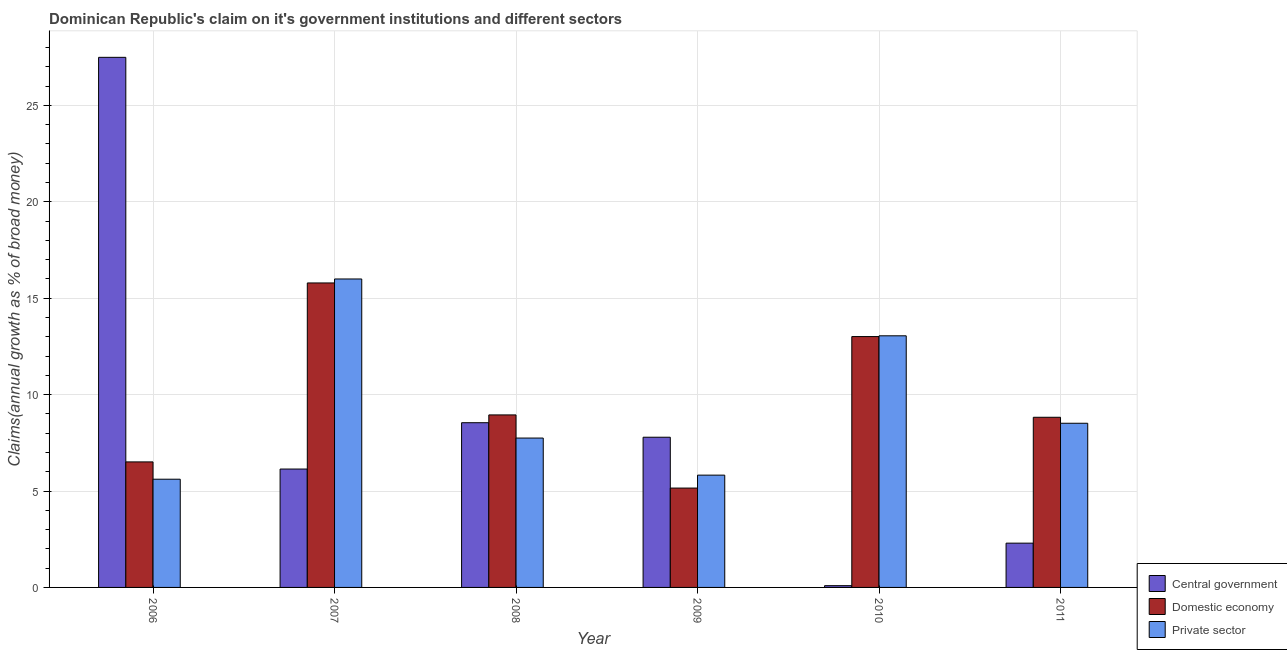How many different coloured bars are there?
Your answer should be very brief. 3. Are the number of bars per tick equal to the number of legend labels?
Offer a very short reply. Yes. Are the number of bars on each tick of the X-axis equal?
Give a very brief answer. Yes. How many bars are there on the 2nd tick from the left?
Make the answer very short. 3. How many bars are there on the 6th tick from the right?
Provide a short and direct response. 3. In how many cases, is the number of bars for a given year not equal to the number of legend labels?
Your response must be concise. 0. What is the percentage of claim on the domestic economy in 2006?
Offer a very short reply. 6.51. Across all years, what is the maximum percentage of claim on the private sector?
Offer a very short reply. 16. Across all years, what is the minimum percentage of claim on the domestic economy?
Provide a short and direct response. 5.15. What is the total percentage of claim on the central government in the graph?
Make the answer very short. 52.36. What is the difference between the percentage of claim on the domestic economy in 2006 and that in 2008?
Provide a succinct answer. -2.44. What is the difference between the percentage of claim on the domestic economy in 2006 and the percentage of claim on the private sector in 2009?
Keep it short and to the point. 1.36. What is the average percentage of claim on the central government per year?
Keep it short and to the point. 8.73. What is the ratio of the percentage of claim on the private sector in 2006 to that in 2008?
Your answer should be very brief. 0.72. What is the difference between the highest and the second highest percentage of claim on the domestic economy?
Keep it short and to the point. 2.78. What is the difference between the highest and the lowest percentage of claim on the domestic economy?
Your answer should be compact. 10.64. Is the sum of the percentage of claim on the private sector in 2007 and 2009 greater than the maximum percentage of claim on the central government across all years?
Ensure brevity in your answer.  Yes. What does the 2nd bar from the left in 2011 represents?
Make the answer very short. Domestic economy. What does the 2nd bar from the right in 2009 represents?
Give a very brief answer. Domestic economy. Is it the case that in every year, the sum of the percentage of claim on the central government and percentage of claim on the domestic economy is greater than the percentage of claim on the private sector?
Offer a very short reply. Yes. How many bars are there?
Keep it short and to the point. 18. Are all the bars in the graph horizontal?
Offer a terse response. No. Are the values on the major ticks of Y-axis written in scientific E-notation?
Offer a terse response. No. Does the graph contain grids?
Your answer should be very brief. Yes. Where does the legend appear in the graph?
Keep it short and to the point. Bottom right. How are the legend labels stacked?
Keep it short and to the point. Vertical. What is the title of the graph?
Your response must be concise. Dominican Republic's claim on it's government institutions and different sectors. What is the label or title of the X-axis?
Ensure brevity in your answer.  Year. What is the label or title of the Y-axis?
Provide a succinct answer. Claims(annual growth as % of broad money). What is the Claims(annual growth as % of broad money) of Central government in 2006?
Your answer should be very brief. 27.49. What is the Claims(annual growth as % of broad money) in Domestic economy in 2006?
Provide a succinct answer. 6.51. What is the Claims(annual growth as % of broad money) in Private sector in 2006?
Give a very brief answer. 5.61. What is the Claims(annual growth as % of broad money) in Central government in 2007?
Provide a short and direct response. 6.14. What is the Claims(annual growth as % of broad money) of Domestic economy in 2007?
Your answer should be compact. 15.79. What is the Claims(annual growth as % of broad money) of Private sector in 2007?
Make the answer very short. 16. What is the Claims(annual growth as % of broad money) in Central government in 2008?
Your response must be concise. 8.54. What is the Claims(annual growth as % of broad money) of Domestic economy in 2008?
Keep it short and to the point. 8.95. What is the Claims(annual growth as % of broad money) of Private sector in 2008?
Make the answer very short. 7.75. What is the Claims(annual growth as % of broad money) of Central government in 2009?
Your answer should be compact. 7.79. What is the Claims(annual growth as % of broad money) of Domestic economy in 2009?
Your answer should be very brief. 5.15. What is the Claims(annual growth as % of broad money) in Private sector in 2009?
Your response must be concise. 5.82. What is the Claims(annual growth as % of broad money) of Central government in 2010?
Ensure brevity in your answer.  0.09. What is the Claims(annual growth as % of broad money) of Domestic economy in 2010?
Ensure brevity in your answer.  13.01. What is the Claims(annual growth as % of broad money) in Private sector in 2010?
Give a very brief answer. 13.05. What is the Claims(annual growth as % of broad money) of Central government in 2011?
Provide a succinct answer. 2.3. What is the Claims(annual growth as % of broad money) of Domestic economy in 2011?
Ensure brevity in your answer.  8.83. What is the Claims(annual growth as % of broad money) in Private sector in 2011?
Offer a very short reply. 8.51. Across all years, what is the maximum Claims(annual growth as % of broad money) of Central government?
Keep it short and to the point. 27.49. Across all years, what is the maximum Claims(annual growth as % of broad money) in Domestic economy?
Ensure brevity in your answer.  15.79. Across all years, what is the maximum Claims(annual growth as % of broad money) in Private sector?
Give a very brief answer. 16. Across all years, what is the minimum Claims(annual growth as % of broad money) of Central government?
Offer a very short reply. 0.09. Across all years, what is the minimum Claims(annual growth as % of broad money) in Domestic economy?
Ensure brevity in your answer.  5.15. Across all years, what is the minimum Claims(annual growth as % of broad money) in Private sector?
Ensure brevity in your answer.  5.61. What is the total Claims(annual growth as % of broad money) of Central government in the graph?
Your answer should be very brief. 52.36. What is the total Claims(annual growth as % of broad money) of Domestic economy in the graph?
Provide a succinct answer. 58.24. What is the total Claims(annual growth as % of broad money) in Private sector in the graph?
Give a very brief answer. 56.75. What is the difference between the Claims(annual growth as % of broad money) of Central government in 2006 and that in 2007?
Make the answer very short. 21.35. What is the difference between the Claims(annual growth as % of broad money) in Domestic economy in 2006 and that in 2007?
Your answer should be compact. -9.28. What is the difference between the Claims(annual growth as % of broad money) in Private sector in 2006 and that in 2007?
Your answer should be very brief. -10.39. What is the difference between the Claims(annual growth as % of broad money) in Central government in 2006 and that in 2008?
Your answer should be very brief. 18.95. What is the difference between the Claims(annual growth as % of broad money) in Domestic economy in 2006 and that in 2008?
Offer a terse response. -2.44. What is the difference between the Claims(annual growth as % of broad money) in Private sector in 2006 and that in 2008?
Your response must be concise. -2.13. What is the difference between the Claims(annual growth as % of broad money) of Central government in 2006 and that in 2009?
Ensure brevity in your answer.  19.7. What is the difference between the Claims(annual growth as % of broad money) in Domestic economy in 2006 and that in 2009?
Your answer should be compact. 1.36. What is the difference between the Claims(annual growth as % of broad money) in Private sector in 2006 and that in 2009?
Provide a short and direct response. -0.21. What is the difference between the Claims(annual growth as % of broad money) of Central government in 2006 and that in 2010?
Provide a short and direct response. 27.4. What is the difference between the Claims(annual growth as % of broad money) of Domestic economy in 2006 and that in 2010?
Your answer should be compact. -6.5. What is the difference between the Claims(annual growth as % of broad money) in Private sector in 2006 and that in 2010?
Your answer should be compact. -7.44. What is the difference between the Claims(annual growth as % of broad money) in Central government in 2006 and that in 2011?
Offer a terse response. 25.2. What is the difference between the Claims(annual growth as % of broad money) of Domestic economy in 2006 and that in 2011?
Make the answer very short. -2.31. What is the difference between the Claims(annual growth as % of broad money) of Private sector in 2006 and that in 2011?
Ensure brevity in your answer.  -2.9. What is the difference between the Claims(annual growth as % of broad money) in Central government in 2007 and that in 2008?
Your response must be concise. -2.4. What is the difference between the Claims(annual growth as % of broad money) of Domestic economy in 2007 and that in 2008?
Offer a very short reply. 6.84. What is the difference between the Claims(annual growth as % of broad money) in Private sector in 2007 and that in 2008?
Provide a short and direct response. 8.25. What is the difference between the Claims(annual growth as % of broad money) in Central government in 2007 and that in 2009?
Give a very brief answer. -1.65. What is the difference between the Claims(annual growth as % of broad money) in Domestic economy in 2007 and that in 2009?
Make the answer very short. 10.64. What is the difference between the Claims(annual growth as % of broad money) of Private sector in 2007 and that in 2009?
Offer a very short reply. 10.17. What is the difference between the Claims(annual growth as % of broad money) of Central government in 2007 and that in 2010?
Offer a very short reply. 6.05. What is the difference between the Claims(annual growth as % of broad money) in Domestic economy in 2007 and that in 2010?
Provide a short and direct response. 2.78. What is the difference between the Claims(annual growth as % of broad money) in Private sector in 2007 and that in 2010?
Make the answer very short. 2.95. What is the difference between the Claims(annual growth as % of broad money) in Central government in 2007 and that in 2011?
Provide a short and direct response. 3.84. What is the difference between the Claims(annual growth as % of broad money) in Domestic economy in 2007 and that in 2011?
Ensure brevity in your answer.  6.97. What is the difference between the Claims(annual growth as % of broad money) in Private sector in 2007 and that in 2011?
Make the answer very short. 7.48. What is the difference between the Claims(annual growth as % of broad money) of Central government in 2008 and that in 2009?
Your answer should be compact. 0.75. What is the difference between the Claims(annual growth as % of broad money) of Domestic economy in 2008 and that in 2009?
Make the answer very short. 3.79. What is the difference between the Claims(annual growth as % of broad money) of Private sector in 2008 and that in 2009?
Offer a terse response. 1.92. What is the difference between the Claims(annual growth as % of broad money) in Central government in 2008 and that in 2010?
Provide a succinct answer. 8.45. What is the difference between the Claims(annual growth as % of broad money) of Domestic economy in 2008 and that in 2010?
Offer a terse response. -4.06. What is the difference between the Claims(annual growth as % of broad money) of Private sector in 2008 and that in 2010?
Make the answer very short. -5.3. What is the difference between the Claims(annual growth as % of broad money) of Central government in 2008 and that in 2011?
Your answer should be very brief. 6.25. What is the difference between the Claims(annual growth as % of broad money) of Domestic economy in 2008 and that in 2011?
Offer a terse response. 0.12. What is the difference between the Claims(annual growth as % of broad money) in Private sector in 2008 and that in 2011?
Provide a short and direct response. -0.77. What is the difference between the Claims(annual growth as % of broad money) of Central government in 2009 and that in 2010?
Give a very brief answer. 7.7. What is the difference between the Claims(annual growth as % of broad money) of Domestic economy in 2009 and that in 2010?
Make the answer very short. -7.86. What is the difference between the Claims(annual growth as % of broad money) of Private sector in 2009 and that in 2010?
Provide a short and direct response. -7.23. What is the difference between the Claims(annual growth as % of broad money) in Central government in 2009 and that in 2011?
Keep it short and to the point. 5.49. What is the difference between the Claims(annual growth as % of broad money) of Domestic economy in 2009 and that in 2011?
Make the answer very short. -3.67. What is the difference between the Claims(annual growth as % of broad money) in Private sector in 2009 and that in 2011?
Your answer should be compact. -2.69. What is the difference between the Claims(annual growth as % of broad money) in Central government in 2010 and that in 2011?
Your response must be concise. -2.21. What is the difference between the Claims(annual growth as % of broad money) in Domestic economy in 2010 and that in 2011?
Keep it short and to the point. 4.19. What is the difference between the Claims(annual growth as % of broad money) in Private sector in 2010 and that in 2011?
Make the answer very short. 4.54. What is the difference between the Claims(annual growth as % of broad money) of Central government in 2006 and the Claims(annual growth as % of broad money) of Domestic economy in 2007?
Provide a short and direct response. 11.7. What is the difference between the Claims(annual growth as % of broad money) in Central government in 2006 and the Claims(annual growth as % of broad money) in Private sector in 2007?
Provide a succinct answer. 11.5. What is the difference between the Claims(annual growth as % of broad money) in Domestic economy in 2006 and the Claims(annual growth as % of broad money) in Private sector in 2007?
Your answer should be compact. -9.49. What is the difference between the Claims(annual growth as % of broad money) of Central government in 2006 and the Claims(annual growth as % of broad money) of Domestic economy in 2008?
Give a very brief answer. 18.55. What is the difference between the Claims(annual growth as % of broad money) of Central government in 2006 and the Claims(annual growth as % of broad money) of Private sector in 2008?
Give a very brief answer. 19.75. What is the difference between the Claims(annual growth as % of broad money) in Domestic economy in 2006 and the Claims(annual growth as % of broad money) in Private sector in 2008?
Your answer should be very brief. -1.24. What is the difference between the Claims(annual growth as % of broad money) of Central government in 2006 and the Claims(annual growth as % of broad money) of Domestic economy in 2009?
Provide a short and direct response. 22.34. What is the difference between the Claims(annual growth as % of broad money) of Central government in 2006 and the Claims(annual growth as % of broad money) of Private sector in 2009?
Your response must be concise. 21.67. What is the difference between the Claims(annual growth as % of broad money) of Domestic economy in 2006 and the Claims(annual growth as % of broad money) of Private sector in 2009?
Make the answer very short. 0.69. What is the difference between the Claims(annual growth as % of broad money) in Central government in 2006 and the Claims(annual growth as % of broad money) in Domestic economy in 2010?
Offer a terse response. 14.48. What is the difference between the Claims(annual growth as % of broad money) of Central government in 2006 and the Claims(annual growth as % of broad money) of Private sector in 2010?
Offer a very short reply. 14.44. What is the difference between the Claims(annual growth as % of broad money) in Domestic economy in 2006 and the Claims(annual growth as % of broad money) in Private sector in 2010?
Provide a succinct answer. -6.54. What is the difference between the Claims(annual growth as % of broad money) in Central government in 2006 and the Claims(annual growth as % of broad money) in Domestic economy in 2011?
Provide a short and direct response. 18.67. What is the difference between the Claims(annual growth as % of broad money) in Central government in 2006 and the Claims(annual growth as % of broad money) in Private sector in 2011?
Provide a succinct answer. 18.98. What is the difference between the Claims(annual growth as % of broad money) of Domestic economy in 2006 and the Claims(annual growth as % of broad money) of Private sector in 2011?
Provide a succinct answer. -2. What is the difference between the Claims(annual growth as % of broad money) of Central government in 2007 and the Claims(annual growth as % of broad money) of Domestic economy in 2008?
Your answer should be compact. -2.81. What is the difference between the Claims(annual growth as % of broad money) of Central government in 2007 and the Claims(annual growth as % of broad money) of Private sector in 2008?
Provide a succinct answer. -1.61. What is the difference between the Claims(annual growth as % of broad money) in Domestic economy in 2007 and the Claims(annual growth as % of broad money) in Private sector in 2008?
Provide a succinct answer. 8.04. What is the difference between the Claims(annual growth as % of broad money) in Central government in 2007 and the Claims(annual growth as % of broad money) in Domestic economy in 2009?
Your response must be concise. 0.99. What is the difference between the Claims(annual growth as % of broad money) of Central government in 2007 and the Claims(annual growth as % of broad money) of Private sector in 2009?
Your answer should be compact. 0.32. What is the difference between the Claims(annual growth as % of broad money) in Domestic economy in 2007 and the Claims(annual growth as % of broad money) in Private sector in 2009?
Provide a short and direct response. 9.97. What is the difference between the Claims(annual growth as % of broad money) in Central government in 2007 and the Claims(annual growth as % of broad money) in Domestic economy in 2010?
Give a very brief answer. -6.87. What is the difference between the Claims(annual growth as % of broad money) of Central government in 2007 and the Claims(annual growth as % of broad money) of Private sector in 2010?
Your answer should be very brief. -6.91. What is the difference between the Claims(annual growth as % of broad money) in Domestic economy in 2007 and the Claims(annual growth as % of broad money) in Private sector in 2010?
Keep it short and to the point. 2.74. What is the difference between the Claims(annual growth as % of broad money) of Central government in 2007 and the Claims(annual growth as % of broad money) of Domestic economy in 2011?
Provide a short and direct response. -2.69. What is the difference between the Claims(annual growth as % of broad money) of Central government in 2007 and the Claims(annual growth as % of broad money) of Private sector in 2011?
Your answer should be very brief. -2.37. What is the difference between the Claims(annual growth as % of broad money) in Domestic economy in 2007 and the Claims(annual growth as % of broad money) in Private sector in 2011?
Make the answer very short. 7.28. What is the difference between the Claims(annual growth as % of broad money) in Central government in 2008 and the Claims(annual growth as % of broad money) in Domestic economy in 2009?
Keep it short and to the point. 3.39. What is the difference between the Claims(annual growth as % of broad money) in Central government in 2008 and the Claims(annual growth as % of broad money) in Private sector in 2009?
Give a very brief answer. 2.72. What is the difference between the Claims(annual growth as % of broad money) in Domestic economy in 2008 and the Claims(annual growth as % of broad money) in Private sector in 2009?
Give a very brief answer. 3.12. What is the difference between the Claims(annual growth as % of broad money) in Central government in 2008 and the Claims(annual growth as % of broad money) in Domestic economy in 2010?
Your answer should be compact. -4.47. What is the difference between the Claims(annual growth as % of broad money) of Central government in 2008 and the Claims(annual growth as % of broad money) of Private sector in 2010?
Give a very brief answer. -4.51. What is the difference between the Claims(annual growth as % of broad money) in Domestic economy in 2008 and the Claims(annual growth as % of broad money) in Private sector in 2010?
Provide a succinct answer. -4.1. What is the difference between the Claims(annual growth as % of broad money) in Central government in 2008 and the Claims(annual growth as % of broad money) in Domestic economy in 2011?
Your response must be concise. -0.28. What is the difference between the Claims(annual growth as % of broad money) of Central government in 2008 and the Claims(annual growth as % of broad money) of Private sector in 2011?
Make the answer very short. 0.03. What is the difference between the Claims(annual growth as % of broad money) of Domestic economy in 2008 and the Claims(annual growth as % of broad money) of Private sector in 2011?
Provide a short and direct response. 0.43. What is the difference between the Claims(annual growth as % of broad money) of Central government in 2009 and the Claims(annual growth as % of broad money) of Domestic economy in 2010?
Offer a terse response. -5.22. What is the difference between the Claims(annual growth as % of broad money) in Central government in 2009 and the Claims(annual growth as % of broad money) in Private sector in 2010?
Ensure brevity in your answer.  -5.26. What is the difference between the Claims(annual growth as % of broad money) in Domestic economy in 2009 and the Claims(annual growth as % of broad money) in Private sector in 2010?
Ensure brevity in your answer.  -7.9. What is the difference between the Claims(annual growth as % of broad money) in Central government in 2009 and the Claims(annual growth as % of broad money) in Domestic economy in 2011?
Your answer should be compact. -1.03. What is the difference between the Claims(annual growth as % of broad money) in Central government in 2009 and the Claims(annual growth as % of broad money) in Private sector in 2011?
Provide a succinct answer. -0.72. What is the difference between the Claims(annual growth as % of broad money) of Domestic economy in 2009 and the Claims(annual growth as % of broad money) of Private sector in 2011?
Give a very brief answer. -3.36. What is the difference between the Claims(annual growth as % of broad money) in Central government in 2010 and the Claims(annual growth as % of broad money) in Domestic economy in 2011?
Give a very brief answer. -8.73. What is the difference between the Claims(annual growth as % of broad money) in Central government in 2010 and the Claims(annual growth as % of broad money) in Private sector in 2011?
Your answer should be very brief. -8.42. What is the difference between the Claims(annual growth as % of broad money) in Domestic economy in 2010 and the Claims(annual growth as % of broad money) in Private sector in 2011?
Provide a succinct answer. 4.5. What is the average Claims(annual growth as % of broad money) in Central government per year?
Your answer should be very brief. 8.73. What is the average Claims(annual growth as % of broad money) of Domestic economy per year?
Provide a succinct answer. 9.71. What is the average Claims(annual growth as % of broad money) in Private sector per year?
Give a very brief answer. 9.46. In the year 2006, what is the difference between the Claims(annual growth as % of broad money) of Central government and Claims(annual growth as % of broad money) of Domestic economy?
Provide a short and direct response. 20.98. In the year 2006, what is the difference between the Claims(annual growth as % of broad money) in Central government and Claims(annual growth as % of broad money) in Private sector?
Offer a very short reply. 21.88. In the year 2006, what is the difference between the Claims(annual growth as % of broad money) of Domestic economy and Claims(annual growth as % of broad money) of Private sector?
Your answer should be very brief. 0.9. In the year 2007, what is the difference between the Claims(annual growth as % of broad money) in Central government and Claims(annual growth as % of broad money) in Domestic economy?
Your response must be concise. -9.65. In the year 2007, what is the difference between the Claims(annual growth as % of broad money) of Central government and Claims(annual growth as % of broad money) of Private sector?
Ensure brevity in your answer.  -9.86. In the year 2007, what is the difference between the Claims(annual growth as % of broad money) in Domestic economy and Claims(annual growth as % of broad money) in Private sector?
Provide a succinct answer. -0.21. In the year 2008, what is the difference between the Claims(annual growth as % of broad money) of Central government and Claims(annual growth as % of broad money) of Domestic economy?
Ensure brevity in your answer.  -0.4. In the year 2008, what is the difference between the Claims(annual growth as % of broad money) of Central government and Claims(annual growth as % of broad money) of Private sector?
Offer a very short reply. 0.8. In the year 2008, what is the difference between the Claims(annual growth as % of broad money) of Domestic economy and Claims(annual growth as % of broad money) of Private sector?
Ensure brevity in your answer.  1.2. In the year 2009, what is the difference between the Claims(annual growth as % of broad money) in Central government and Claims(annual growth as % of broad money) in Domestic economy?
Provide a succinct answer. 2.64. In the year 2009, what is the difference between the Claims(annual growth as % of broad money) of Central government and Claims(annual growth as % of broad money) of Private sector?
Make the answer very short. 1.97. In the year 2009, what is the difference between the Claims(annual growth as % of broad money) in Domestic economy and Claims(annual growth as % of broad money) in Private sector?
Ensure brevity in your answer.  -0.67. In the year 2010, what is the difference between the Claims(annual growth as % of broad money) of Central government and Claims(annual growth as % of broad money) of Domestic economy?
Your answer should be compact. -12.92. In the year 2010, what is the difference between the Claims(annual growth as % of broad money) of Central government and Claims(annual growth as % of broad money) of Private sector?
Your answer should be compact. -12.96. In the year 2010, what is the difference between the Claims(annual growth as % of broad money) of Domestic economy and Claims(annual growth as % of broad money) of Private sector?
Your response must be concise. -0.04. In the year 2011, what is the difference between the Claims(annual growth as % of broad money) in Central government and Claims(annual growth as % of broad money) in Domestic economy?
Your answer should be very brief. -6.53. In the year 2011, what is the difference between the Claims(annual growth as % of broad money) of Central government and Claims(annual growth as % of broad money) of Private sector?
Provide a succinct answer. -6.22. In the year 2011, what is the difference between the Claims(annual growth as % of broad money) in Domestic economy and Claims(annual growth as % of broad money) in Private sector?
Offer a very short reply. 0.31. What is the ratio of the Claims(annual growth as % of broad money) of Central government in 2006 to that in 2007?
Provide a succinct answer. 4.48. What is the ratio of the Claims(annual growth as % of broad money) of Domestic economy in 2006 to that in 2007?
Offer a terse response. 0.41. What is the ratio of the Claims(annual growth as % of broad money) in Private sector in 2006 to that in 2007?
Provide a short and direct response. 0.35. What is the ratio of the Claims(annual growth as % of broad money) in Central government in 2006 to that in 2008?
Your answer should be compact. 3.22. What is the ratio of the Claims(annual growth as % of broad money) of Domestic economy in 2006 to that in 2008?
Your response must be concise. 0.73. What is the ratio of the Claims(annual growth as % of broad money) in Private sector in 2006 to that in 2008?
Give a very brief answer. 0.72. What is the ratio of the Claims(annual growth as % of broad money) in Central government in 2006 to that in 2009?
Provide a short and direct response. 3.53. What is the ratio of the Claims(annual growth as % of broad money) in Domestic economy in 2006 to that in 2009?
Ensure brevity in your answer.  1.26. What is the ratio of the Claims(annual growth as % of broad money) of Private sector in 2006 to that in 2009?
Your response must be concise. 0.96. What is the ratio of the Claims(annual growth as % of broad money) of Central government in 2006 to that in 2010?
Make the answer very short. 300.95. What is the ratio of the Claims(annual growth as % of broad money) of Domestic economy in 2006 to that in 2010?
Ensure brevity in your answer.  0.5. What is the ratio of the Claims(annual growth as % of broad money) in Private sector in 2006 to that in 2010?
Keep it short and to the point. 0.43. What is the ratio of the Claims(annual growth as % of broad money) in Central government in 2006 to that in 2011?
Your answer should be compact. 11.97. What is the ratio of the Claims(annual growth as % of broad money) of Domestic economy in 2006 to that in 2011?
Your answer should be compact. 0.74. What is the ratio of the Claims(annual growth as % of broad money) of Private sector in 2006 to that in 2011?
Provide a short and direct response. 0.66. What is the ratio of the Claims(annual growth as % of broad money) in Central government in 2007 to that in 2008?
Offer a very short reply. 0.72. What is the ratio of the Claims(annual growth as % of broad money) in Domestic economy in 2007 to that in 2008?
Your response must be concise. 1.76. What is the ratio of the Claims(annual growth as % of broad money) of Private sector in 2007 to that in 2008?
Provide a short and direct response. 2.06. What is the ratio of the Claims(annual growth as % of broad money) of Central government in 2007 to that in 2009?
Provide a short and direct response. 0.79. What is the ratio of the Claims(annual growth as % of broad money) in Domestic economy in 2007 to that in 2009?
Ensure brevity in your answer.  3.06. What is the ratio of the Claims(annual growth as % of broad money) in Private sector in 2007 to that in 2009?
Offer a terse response. 2.75. What is the ratio of the Claims(annual growth as % of broad money) in Central government in 2007 to that in 2010?
Give a very brief answer. 67.21. What is the ratio of the Claims(annual growth as % of broad money) in Domestic economy in 2007 to that in 2010?
Offer a very short reply. 1.21. What is the ratio of the Claims(annual growth as % of broad money) of Private sector in 2007 to that in 2010?
Offer a very short reply. 1.23. What is the ratio of the Claims(annual growth as % of broad money) in Central government in 2007 to that in 2011?
Your answer should be compact. 2.67. What is the ratio of the Claims(annual growth as % of broad money) of Domestic economy in 2007 to that in 2011?
Your answer should be compact. 1.79. What is the ratio of the Claims(annual growth as % of broad money) of Private sector in 2007 to that in 2011?
Offer a very short reply. 1.88. What is the ratio of the Claims(annual growth as % of broad money) of Central government in 2008 to that in 2009?
Provide a short and direct response. 1.1. What is the ratio of the Claims(annual growth as % of broad money) of Domestic economy in 2008 to that in 2009?
Give a very brief answer. 1.74. What is the ratio of the Claims(annual growth as % of broad money) of Private sector in 2008 to that in 2009?
Make the answer very short. 1.33. What is the ratio of the Claims(annual growth as % of broad money) of Central government in 2008 to that in 2010?
Your answer should be very brief. 93.51. What is the ratio of the Claims(annual growth as % of broad money) of Domestic economy in 2008 to that in 2010?
Ensure brevity in your answer.  0.69. What is the ratio of the Claims(annual growth as % of broad money) of Private sector in 2008 to that in 2010?
Your answer should be compact. 0.59. What is the ratio of the Claims(annual growth as % of broad money) of Central government in 2008 to that in 2011?
Your answer should be compact. 3.72. What is the ratio of the Claims(annual growth as % of broad money) in Domestic economy in 2008 to that in 2011?
Give a very brief answer. 1.01. What is the ratio of the Claims(annual growth as % of broad money) of Private sector in 2008 to that in 2011?
Offer a terse response. 0.91. What is the ratio of the Claims(annual growth as % of broad money) of Central government in 2009 to that in 2010?
Your answer should be compact. 85.27. What is the ratio of the Claims(annual growth as % of broad money) of Domestic economy in 2009 to that in 2010?
Your response must be concise. 0.4. What is the ratio of the Claims(annual growth as % of broad money) in Private sector in 2009 to that in 2010?
Offer a terse response. 0.45. What is the ratio of the Claims(annual growth as % of broad money) of Central government in 2009 to that in 2011?
Keep it short and to the point. 3.39. What is the ratio of the Claims(annual growth as % of broad money) of Domestic economy in 2009 to that in 2011?
Keep it short and to the point. 0.58. What is the ratio of the Claims(annual growth as % of broad money) of Private sector in 2009 to that in 2011?
Offer a terse response. 0.68. What is the ratio of the Claims(annual growth as % of broad money) in Central government in 2010 to that in 2011?
Provide a succinct answer. 0.04. What is the ratio of the Claims(annual growth as % of broad money) in Domestic economy in 2010 to that in 2011?
Ensure brevity in your answer.  1.47. What is the ratio of the Claims(annual growth as % of broad money) in Private sector in 2010 to that in 2011?
Offer a very short reply. 1.53. What is the difference between the highest and the second highest Claims(annual growth as % of broad money) of Central government?
Offer a very short reply. 18.95. What is the difference between the highest and the second highest Claims(annual growth as % of broad money) of Domestic economy?
Your response must be concise. 2.78. What is the difference between the highest and the second highest Claims(annual growth as % of broad money) in Private sector?
Make the answer very short. 2.95. What is the difference between the highest and the lowest Claims(annual growth as % of broad money) of Central government?
Your response must be concise. 27.4. What is the difference between the highest and the lowest Claims(annual growth as % of broad money) of Domestic economy?
Your answer should be compact. 10.64. What is the difference between the highest and the lowest Claims(annual growth as % of broad money) in Private sector?
Ensure brevity in your answer.  10.39. 